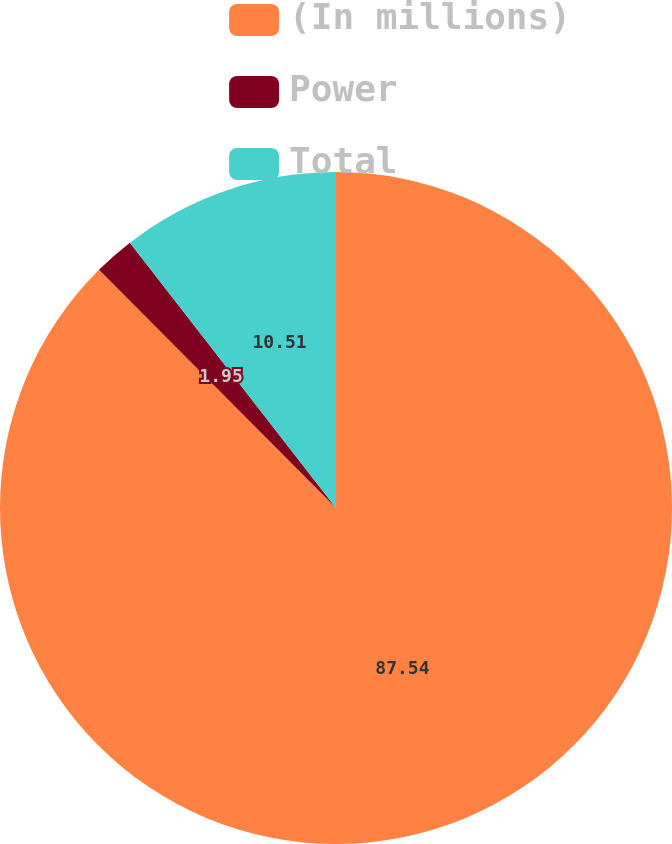<chart> <loc_0><loc_0><loc_500><loc_500><pie_chart><fcel>(In millions)<fcel>Power<fcel>Total<nl><fcel>87.53%<fcel>1.95%<fcel>10.51%<nl></chart> 